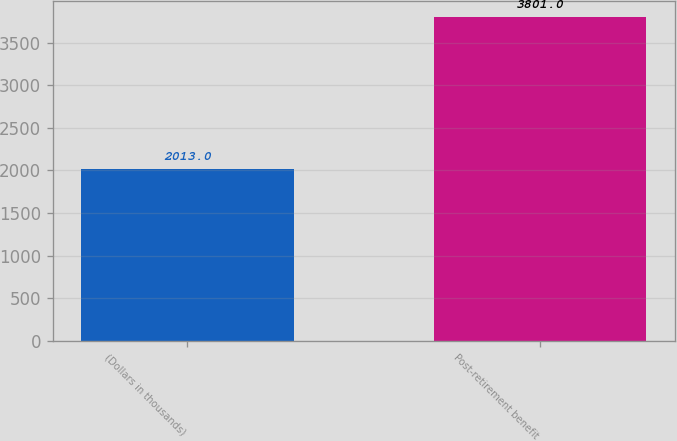Convert chart to OTSL. <chart><loc_0><loc_0><loc_500><loc_500><bar_chart><fcel>(Dollars in thousands)<fcel>Post-retirement benefit<nl><fcel>2013<fcel>3801<nl></chart> 